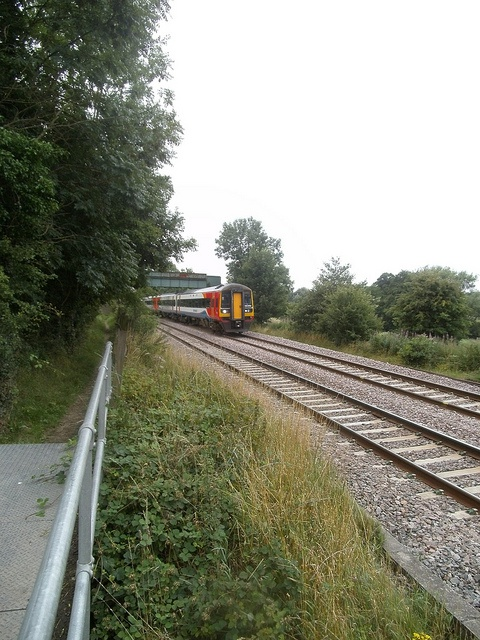Describe the objects in this image and their specific colors. I can see a train in black, gray, darkgray, and maroon tones in this image. 